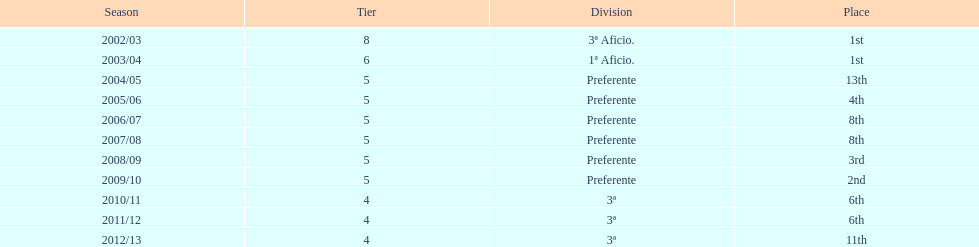Which division ranked above aficio 1a and 3a? Preferente. Could you parse the entire table? {'header': ['Season', 'Tier', 'Division', 'Place'], 'rows': [['2002/03', '8', '3ª Aficio.', '1st'], ['2003/04', '6', '1ª Aficio.', '1st'], ['2004/05', '5', 'Preferente', '13th'], ['2005/06', '5', 'Preferente', '4th'], ['2006/07', '5', 'Preferente', '8th'], ['2007/08', '5', 'Preferente', '8th'], ['2008/09', '5', 'Preferente', '3rd'], ['2009/10', '5', 'Preferente', '2nd'], ['2010/11', '4', '3ª', '6th'], ['2011/12', '4', '3ª', '6th'], ['2012/13', '4', '3ª', '11th']]} 